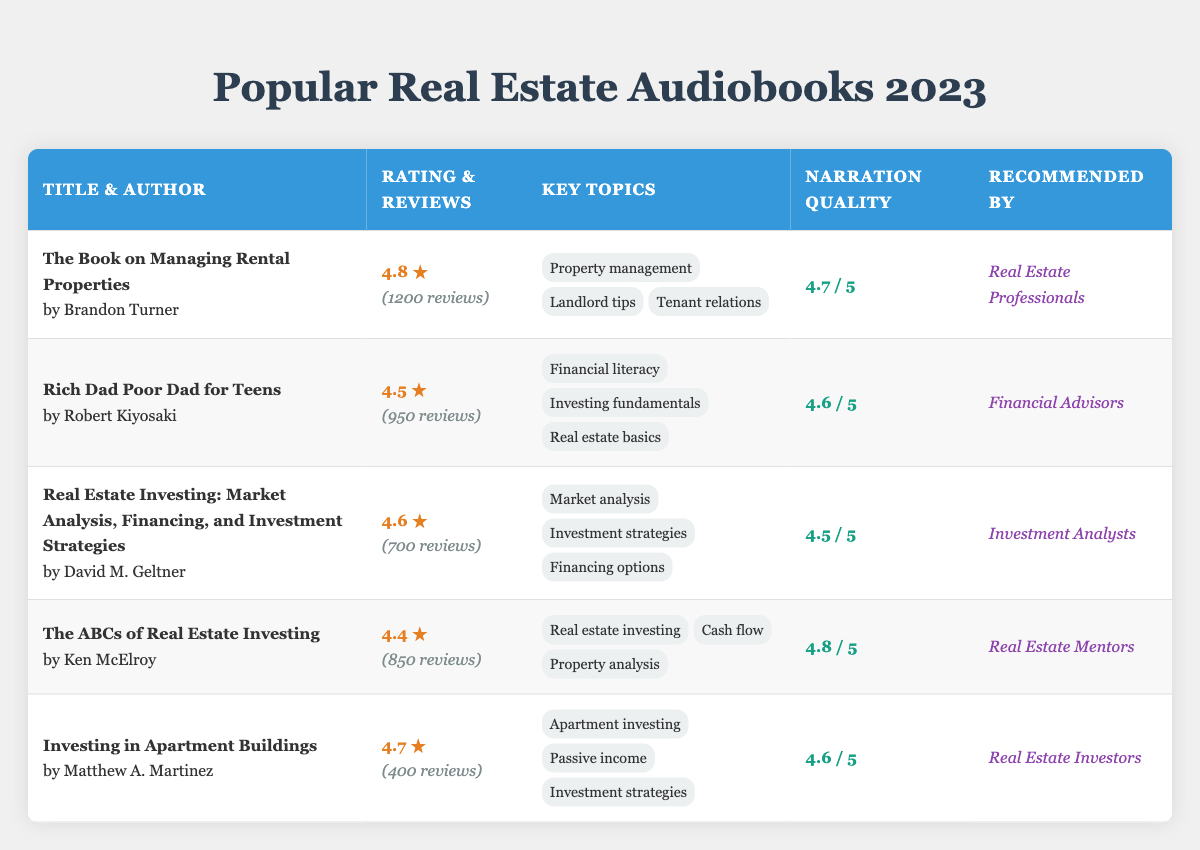What is the highest-rated audiobook in the table? The highest rating in the table is 4.8, which belongs to "The Book on Managing Rental Properties" by Brandon Turner.
Answer: 4.8 How many reviews did "Investing in Apartment Buildings" receive? According to the table, "Investing in Apartment Buildings" received 400 reviews as indicated in the reviews column.
Answer: 400 What are the key topics of "Rich Dad Poor Dad for Teens"? The key topics for "Rich Dad Poor Dad for Teens" by Robert Kiyosaki, as shown in the table, are Financial literacy, Investing fundamentals, and Real estate basics.
Answer: Financial literacy, Investing fundamentals, Real estate basics Is "The ABCs of Real Estate Investing" recommended by Real Estate Professionals? No, "The ABCs of Real Estate Investing" is recommended by Real Estate Mentors, not Real Estate Professionals.
Answer: No What is the average narration quality of the audiobooks in the table? To find the average narration quality, we sum the individual scores: (4.7 + 4.6 + 4.5 + 4.8 + 4.6) = 23.2. Then, we divide by 5 (the number of audiobooks), giving us an average of 23.2/5 = 4.64.
Answer: 4.64 Which audiobook has the lowest number of reviews? By comparing the number of reviews, "Investing in Apartment Buildings" has the lowest with 400 reviews, while others have more.
Answer: Investing in Apartment Buildings Which author is associated with both investment strategies and financing options? The author David M. Geltner, associated with "Real Estate Investing: Market Analysis, Financing, and Investment Strategies," covers both investment strategies and financing options, as indicated in the key topics.
Answer: David M. Geltner What percentage of the total reviews does "The Book on Managing Rental Properties" represent? The total number of reviews is 1200 + 950 + 700 + 850 + 400 = 4100. The percentage for "The Book on Managing Rental Properties" is (1200 / 4100) * 100 = 29.27%.
Answer: 29.27% How many audiobooks have a rating of 4.6 or higher? The table shows that 4 audiobooks have a rating of 4.6 or higher: "The Book on Managing Rental Properties" (4.8), "Investing in Apartment Buildings" (4.7), "Rich Dad Poor Dad for Teens" (4.5), and "Real Estate Investing" (4.6).
Answer: 4 